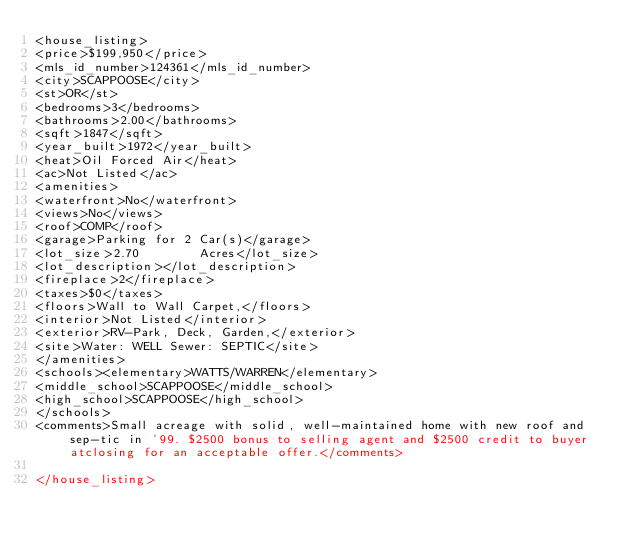<code> <loc_0><loc_0><loc_500><loc_500><_XML_><house_listing>
<price>$199,950</price>
<mls_id_number>124361</mls_id_number>
<city>SCAPPOOSE</city>
<st>OR</st>
<bedrooms>3</bedrooms>
<bathrooms>2.00</bathrooms>
<sqft>1847</sqft>
<year_built>1972</year_built>
<heat>Oil Forced Air</heat>
<ac>Not Listed</ac>
<amenities>
<waterfront>No</waterfront>
<views>No</views>
<roof>COMP</roof>
<garage>Parking for 2 Car(s)</garage>
<lot_size>2.70        Acres</lot_size>
<lot_description></lot_description>
<fireplace>2</fireplace>
<taxes>$0</taxes>
<floors>Wall to Wall Carpet,</floors>
<interior>Not Listed</interior>
<exterior>RV-Park, Deck, Garden,</exterior>
<site>Water: WELL Sewer: SEPTIC</site>
</amenities>
<schools><elementary>WATTS/WARREN</elementary>
<middle_school>SCAPPOOSE</middle_school>
<high_school>SCAPPOOSE</high_school>
</schools>
<comments>Small acreage with solid, well-maintained home with new roof and sep-tic in '99. $2500 bonus to selling agent and $2500 credit to buyer atclosing for an acceptable offer.</comments>

</house_listing>



</code> 